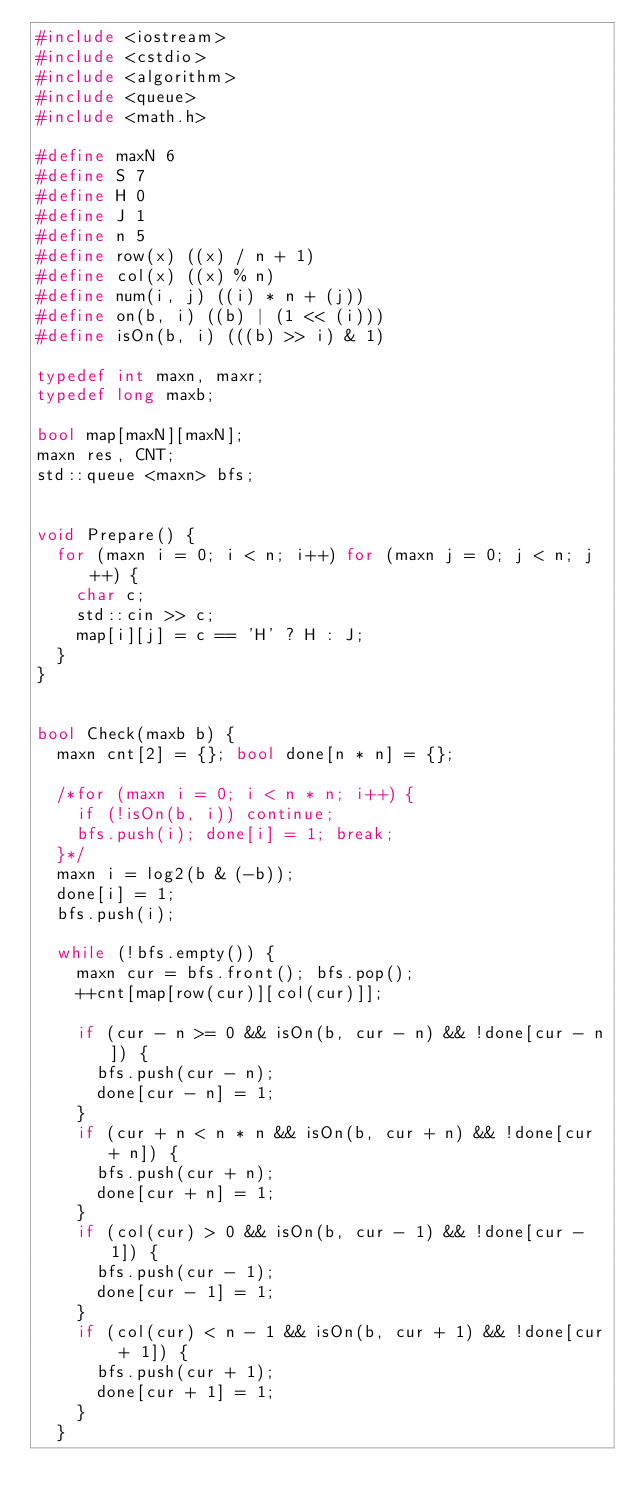<code> <loc_0><loc_0><loc_500><loc_500><_C++_>#include <iostream>
#include <cstdio>
#include <algorithm>
#include <queue>
#include <math.h>

#define maxN 6
#define S 7
#define H 0
#define J 1
#define n 5
#define row(x) ((x) / n + 1)
#define col(x) ((x) % n)
#define num(i, j) ((i) * n + (j))
#define on(b, i) ((b) | (1 << (i)))
#define isOn(b, i) (((b) >> i) & 1)

typedef int maxn, maxr;
typedef long maxb;

bool map[maxN][maxN];
maxn res, CNT;
std::queue <maxn> bfs;


void Prepare() {
	for (maxn i = 0; i < n; i++) for (maxn j = 0; j < n; j++) {
		char c;
		std::cin >> c;
		map[i][j] = c == 'H' ? H : J;
	}
}


bool Check(maxb b) {
	maxn cnt[2] = {}; bool done[n * n] = {};

	/*for (maxn i = 0; i < n * n; i++) {
		if (!isOn(b, i)) continue;
		bfs.push(i); done[i] = 1; break;
	}*/
	maxn i = log2(b & (-b));
	done[i] = 1;
	bfs.push(i);

	while (!bfs.empty()) {
		maxn cur = bfs.front(); bfs.pop();
		++cnt[map[row(cur)][col(cur)]];

		if (cur - n >= 0 && isOn(b, cur - n) && !done[cur - n]) {
			bfs.push(cur - n);
			done[cur - n] = 1;
		}
		if (cur + n < n * n && isOn(b, cur + n) && !done[cur + n]) {
			bfs.push(cur + n);
			done[cur + n] = 1;
		}
		if (col(cur) > 0 && isOn(b, cur - 1) && !done[cur - 1]) {
			bfs.push(cur - 1);
			done[cur - 1] = 1;
		}
		if (col(cur) < n - 1 && isOn(b, cur + 1) && !done[cur + 1]) {
			bfs.push(cur + 1);
			done[cur + 1] = 1;
		}
	}
</code> 